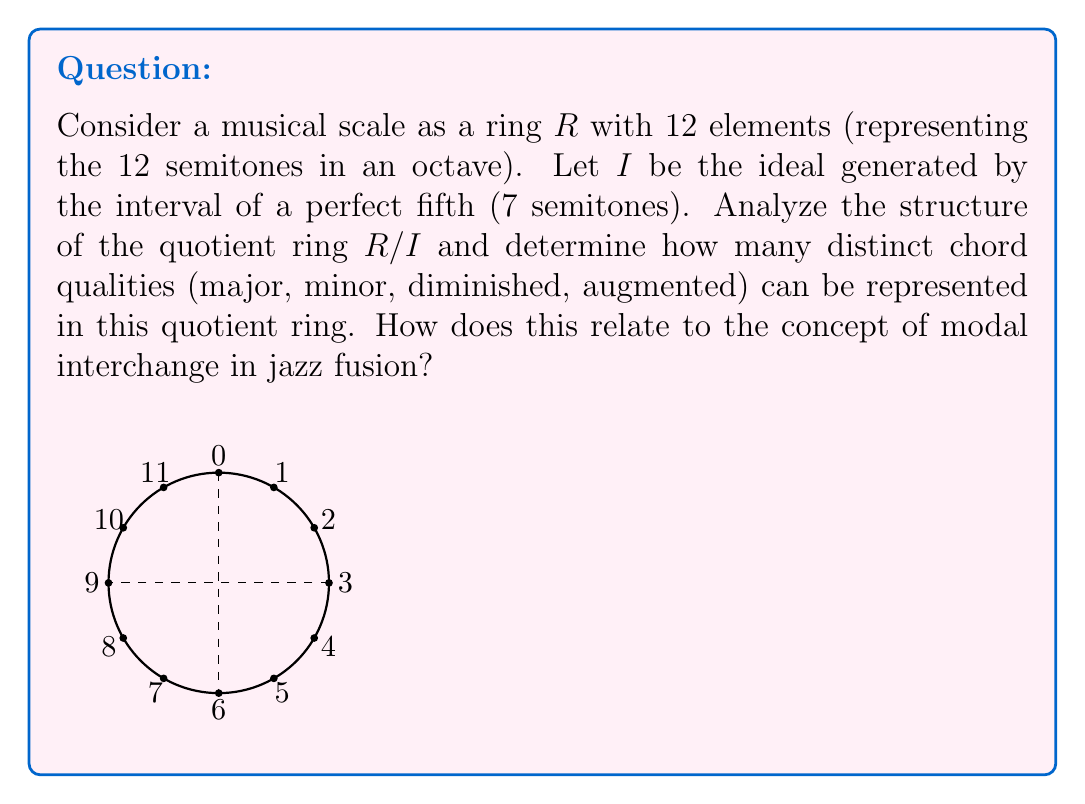Teach me how to tackle this problem. Let's approach this step-by-step:

1) First, we need to understand the structure of $R/I$:
   - $R$ is the ring of integers modulo 12, i.e., $\mathbb{Z}_{12}$
   - $I$ is generated by 7, so $I = \{0, 7\}$ in $\mathbb{Z}_{12}$

2) The quotient ring $R/I$ will have elements of the form $[x] = \{x, x+7\}$ where $x \in \{0,1,2,3,4,5,6\}$

3) This means $R/I$ has 6 distinct elements: $[0], [1], [2], [3], [4], [5]$

4) The structure of $R/I$ is isomorphic to $\mathbb{Z}_6$

5) In music theory, chord qualities are determined by the intervals between notes. In $R/I$:
   - Major third = minor sixth = [4]
   - Minor third = major sixth = [3]
   - Perfect fourth = perfect fifth = [5]

6) Given these intervals, we can represent:
   - Major chords: [0], [4], [7] becomes [0], [4], [0] in $R/I$
   - Minor chords: [0], [3], [7] becomes [0], [3], [0] in $R/I$
   - Diminished chords: [0], [3], [6] becomes [0], [3], [5] in $R/I$
   - Augmented chords: [0], [4], [8] becomes [0], [4], [1] in $R/I$

7) Therefore, all four chord qualities (major, minor, diminished, augmented) can be represented in $R/I$

8) In jazz fusion, modal interchange involves borrowing chords from parallel modes. The structure of $R/I$ allows for this by preserving the relationships between different chord qualities while simplifying the harmonic space. This can facilitate complex harmonic movements and substitutions common in jazz fusion.
Answer: 4 chord qualities; facilitates modal interchange 